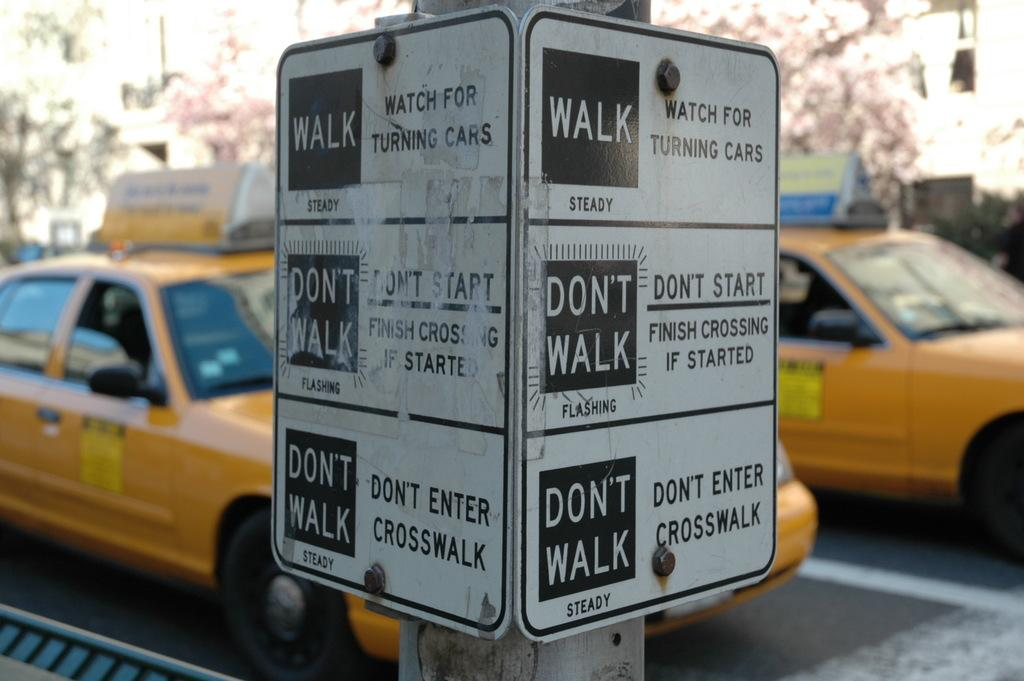<image>
Relay a brief, clear account of the picture shown. The Walk sign at the top warns to watch for turning cars. 